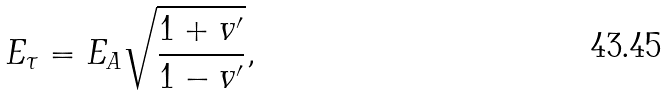Convert formula to latex. <formula><loc_0><loc_0><loc_500><loc_500>E _ { \tau } = E _ { A } \sqrt { \frac { 1 + v ^ { \prime } } { 1 - v ^ { \prime } } } ,</formula> 